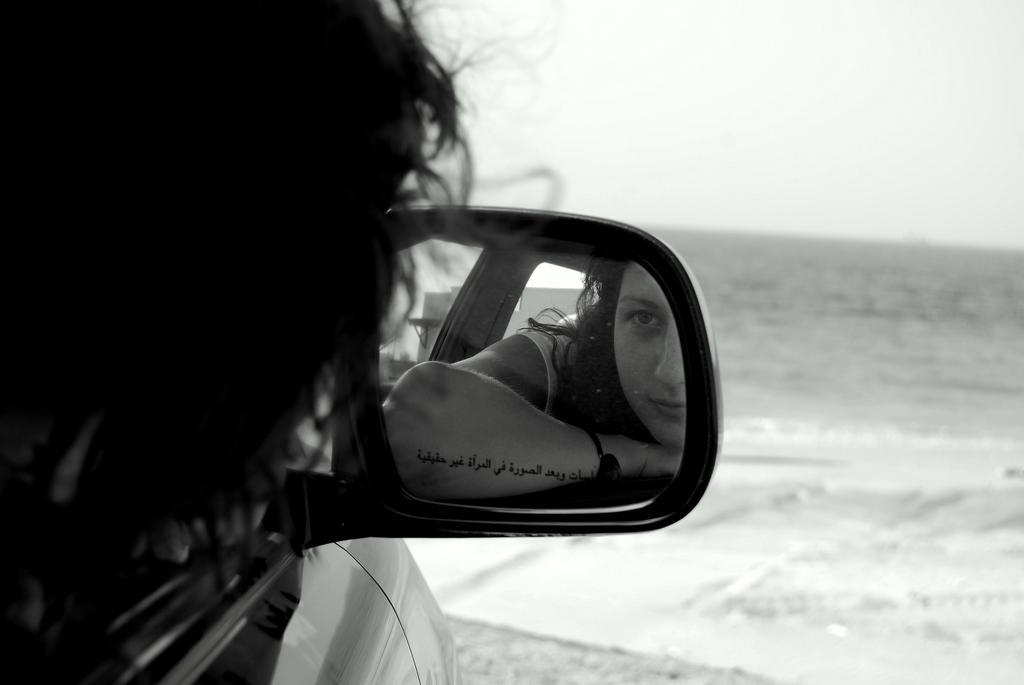In one or two sentences, can you explain what this image depicts? In this picture there is a woman looking in the mirror of a car and then the backdrop does a water body and sky is clear 